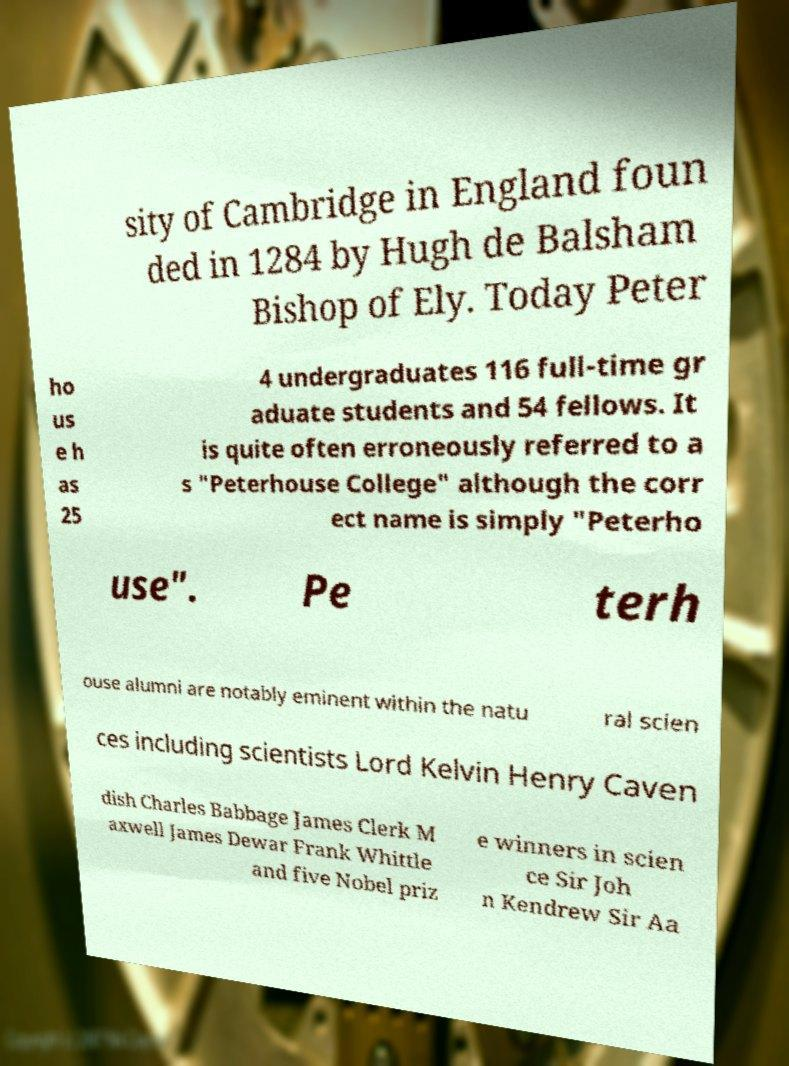Can you read and provide the text displayed in the image?This photo seems to have some interesting text. Can you extract and type it out for me? sity of Cambridge in England foun ded in 1284 by Hugh de Balsham Bishop of Ely. Today Peter ho us e h as 25 4 undergraduates 116 full-time gr aduate students and 54 fellows. It is quite often erroneously referred to a s "Peterhouse College" although the corr ect name is simply "Peterho use". Pe terh ouse alumni are notably eminent within the natu ral scien ces including scientists Lord Kelvin Henry Caven dish Charles Babbage James Clerk M axwell James Dewar Frank Whittle and five Nobel priz e winners in scien ce Sir Joh n Kendrew Sir Aa 